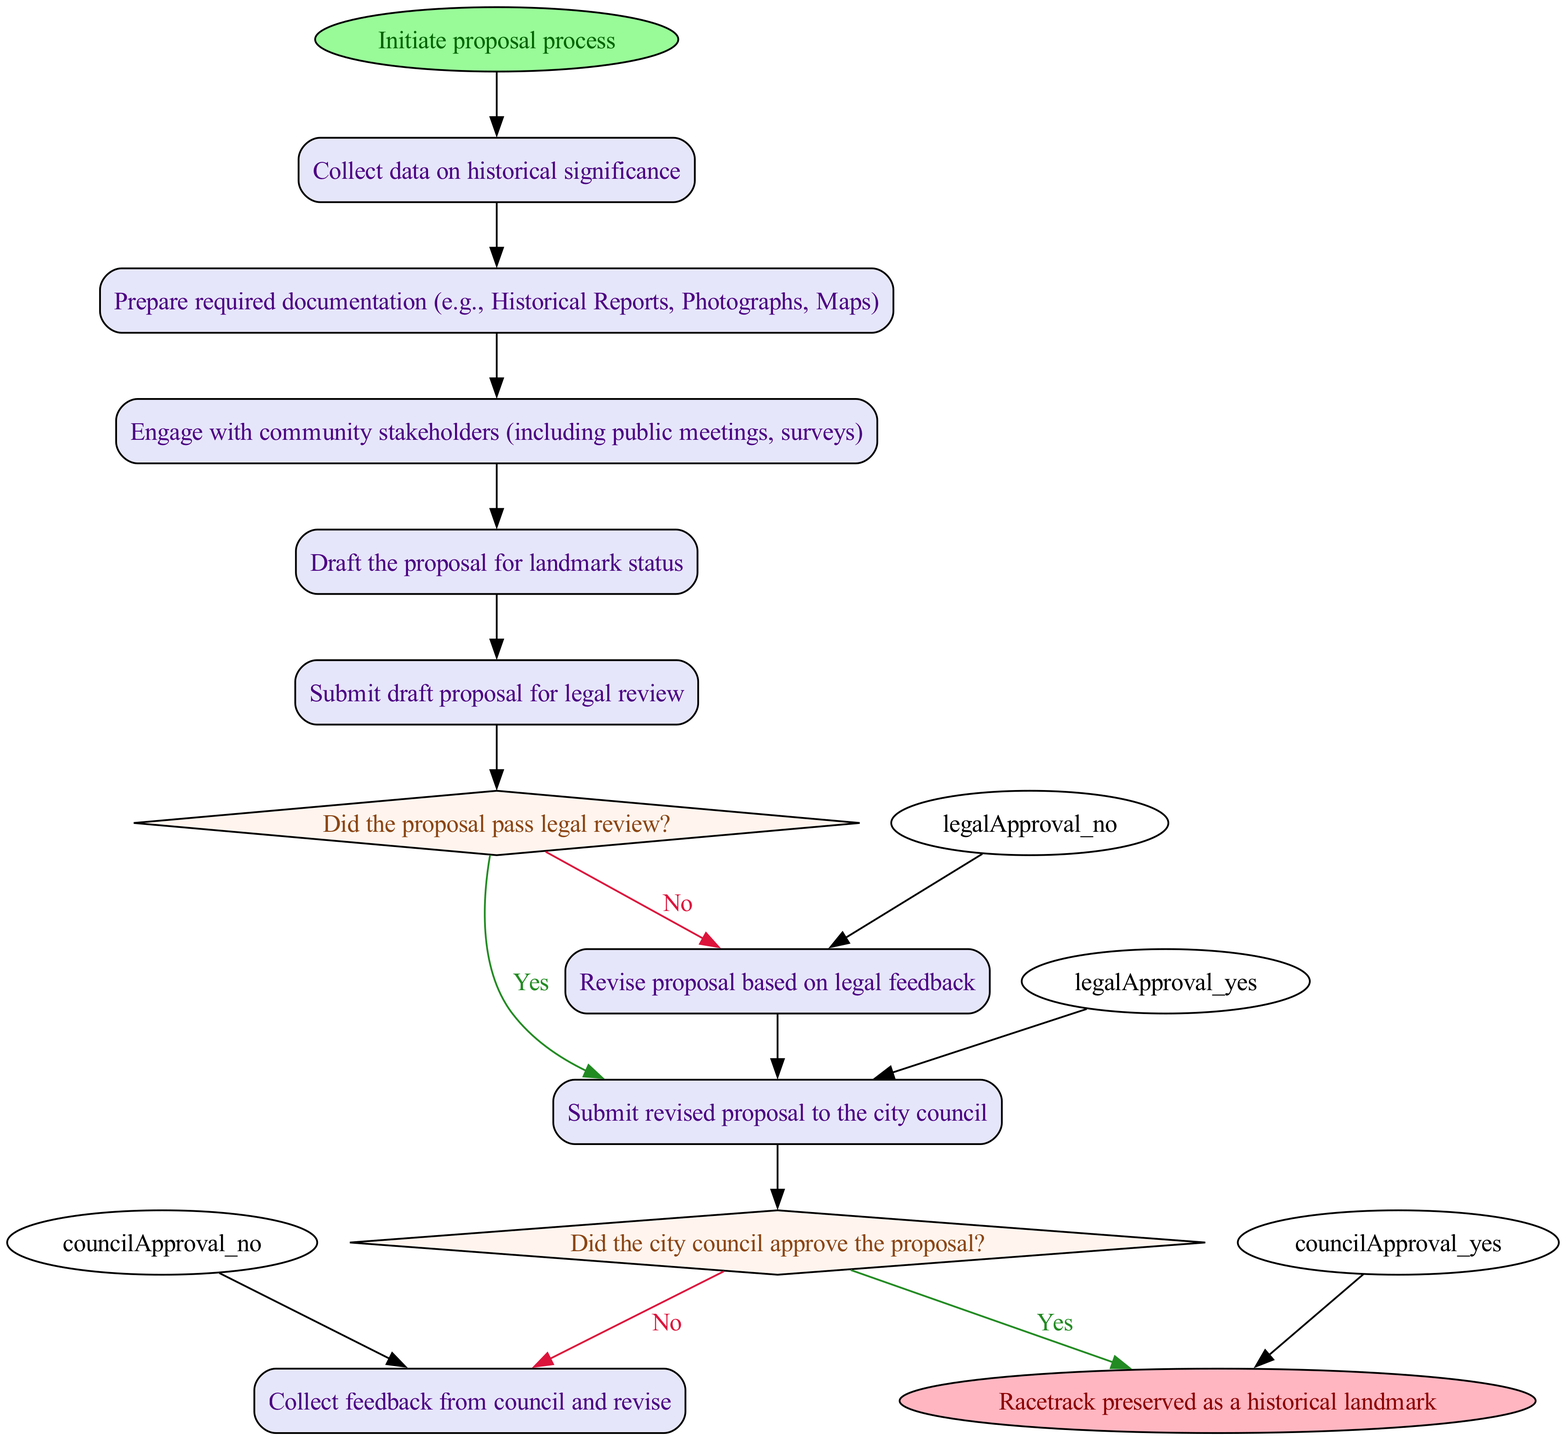What is the first action in the proposal process? The first action in the diagram is labeled "Collect data on historical significance," which follows the "Initiate proposal process" starting node. This indicates it is the first step taken after the process begins.
Answer: Collect data on historical significance How many decision points are in the diagram? The diagram features two decision points, marked with diamond shapes: "Did the proposal pass legal review?" and "Did the city council approve the proposal?" Each of these points requires a yes or no response.
Answer: 2 What happens if the proposal passes the legal review? If the proposal passes the legal review, the next action taken is "Submit revised proposal to the city council," indicating that approval leads directly to submission for further consideration.
Answer: Submit revised proposal to the city council Which action comes after "Prepare required documentation"? After "Prepare required documentation," the next action is "Engage with community stakeholders." This shows the sequence where documentation is finished before engaging the community.
Answer: Engage with community stakeholders What is the outcome if the city council approves the proposal? If the city council approves the proposal, the final outcome is "Racetrack preserved as a historical landmark," signifying a successful culmination of the proposal process and its acceptance.
Answer: Racetrack preserved as a historical landmark What is the last action before submitting the proposal to the city council? Prior to submitting the proposal to the city council, the last action is "Revise proposal based on legal feedback." This step must be completed based on legal review before proceeding to the council.
Answer: Revise proposal based on legal feedback How many actions need to be completed before drafting the proposal? There are three actions that must be completed before drafting the proposal: "Collect data on historical significance," "Prepare required documentation," and "Engage with community stakeholders." Each of these steps is a prerequisite for drafting the proposal.
Answer: 3 What happens if the proposal does not pass legal review? If the proposal does not pass legal review, the next step is to "Revise proposal based on legal feedback," indicating the need to rectify issues highlighted during the review process before resubmission.
Answer: Revise proposal based on legal feedback 